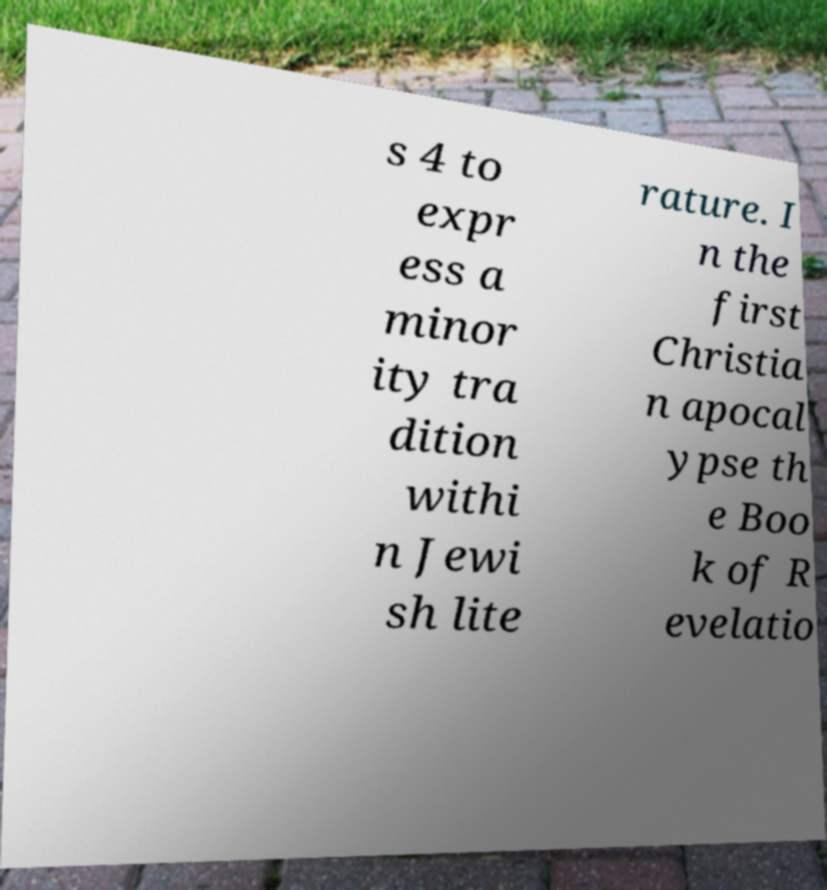Please identify and transcribe the text found in this image. s 4 to expr ess a minor ity tra dition withi n Jewi sh lite rature. I n the first Christia n apocal ypse th e Boo k of R evelatio 